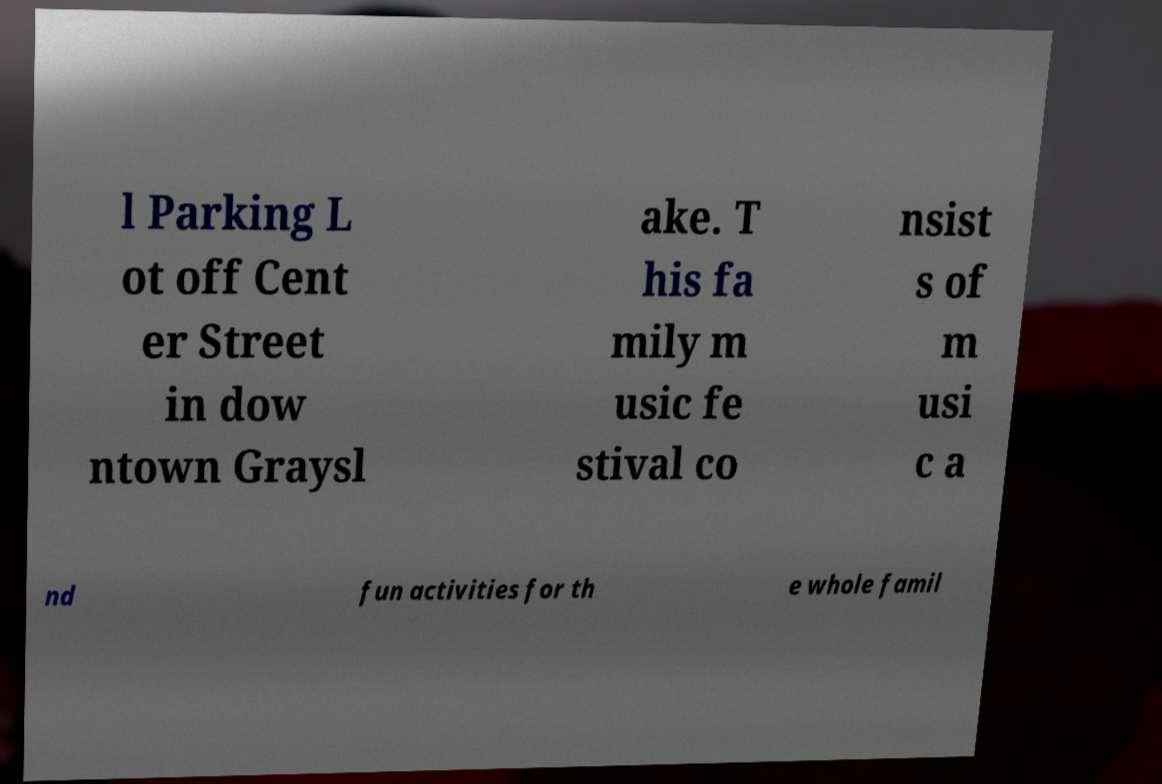Please identify and transcribe the text found in this image. l Parking L ot off Cent er Street in dow ntown Graysl ake. T his fa mily m usic fe stival co nsist s of m usi c a nd fun activities for th e whole famil 